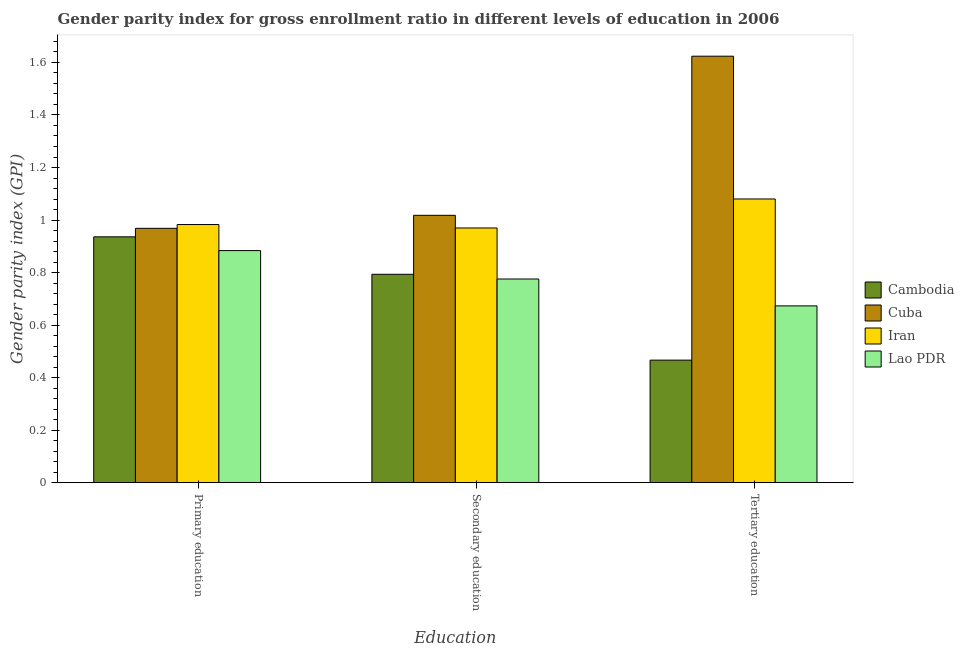How many bars are there on the 1st tick from the left?
Your answer should be very brief. 4. What is the label of the 1st group of bars from the left?
Your answer should be compact. Primary education. What is the gender parity index in primary education in Cambodia?
Make the answer very short. 0.94. Across all countries, what is the maximum gender parity index in primary education?
Ensure brevity in your answer.  0.98. Across all countries, what is the minimum gender parity index in tertiary education?
Provide a short and direct response. 0.47. In which country was the gender parity index in primary education maximum?
Offer a very short reply. Iran. In which country was the gender parity index in tertiary education minimum?
Offer a very short reply. Cambodia. What is the total gender parity index in tertiary education in the graph?
Keep it short and to the point. 3.84. What is the difference between the gender parity index in secondary education in Iran and that in Cuba?
Keep it short and to the point. -0.05. What is the difference between the gender parity index in secondary education in Iran and the gender parity index in tertiary education in Lao PDR?
Your answer should be compact. 0.3. What is the average gender parity index in primary education per country?
Provide a succinct answer. 0.94. What is the difference between the gender parity index in secondary education and gender parity index in primary education in Cuba?
Give a very brief answer. 0.05. In how many countries, is the gender parity index in tertiary education greater than 1.04 ?
Provide a short and direct response. 2. What is the ratio of the gender parity index in secondary education in Cuba to that in Iran?
Make the answer very short. 1.05. What is the difference between the highest and the second highest gender parity index in primary education?
Your answer should be compact. 0.01. What is the difference between the highest and the lowest gender parity index in secondary education?
Provide a succinct answer. 0.24. In how many countries, is the gender parity index in tertiary education greater than the average gender parity index in tertiary education taken over all countries?
Provide a short and direct response. 2. What does the 3rd bar from the left in Primary education represents?
Your answer should be very brief. Iran. What does the 1st bar from the right in Tertiary education represents?
Provide a short and direct response. Lao PDR. Is it the case that in every country, the sum of the gender parity index in primary education and gender parity index in secondary education is greater than the gender parity index in tertiary education?
Keep it short and to the point. Yes. How many bars are there?
Provide a short and direct response. 12. How many countries are there in the graph?
Offer a very short reply. 4. What is the difference between two consecutive major ticks on the Y-axis?
Offer a terse response. 0.2. Are the values on the major ticks of Y-axis written in scientific E-notation?
Keep it short and to the point. No. Does the graph contain any zero values?
Your answer should be very brief. No. Where does the legend appear in the graph?
Provide a succinct answer. Center right. How are the legend labels stacked?
Offer a terse response. Vertical. What is the title of the graph?
Offer a very short reply. Gender parity index for gross enrollment ratio in different levels of education in 2006. What is the label or title of the X-axis?
Your response must be concise. Education. What is the label or title of the Y-axis?
Keep it short and to the point. Gender parity index (GPI). What is the Gender parity index (GPI) in Cambodia in Primary education?
Offer a terse response. 0.94. What is the Gender parity index (GPI) of Cuba in Primary education?
Provide a succinct answer. 0.97. What is the Gender parity index (GPI) in Iran in Primary education?
Provide a short and direct response. 0.98. What is the Gender parity index (GPI) of Lao PDR in Primary education?
Provide a succinct answer. 0.88. What is the Gender parity index (GPI) in Cambodia in Secondary education?
Keep it short and to the point. 0.79. What is the Gender parity index (GPI) of Cuba in Secondary education?
Keep it short and to the point. 1.02. What is the Gender parity index (GPI) in Iran in Secondary education?
Offer a very short reply. 0.97. What is the Gender parity index (GPI) of Lao PDR in Secondary education?
Provide a short and direct response. 0.78. What is the Gender parity index (GPI) of Cambodia in Tertiary education?
Keep it short and to the point. 0.47. What is the Gender parity index (GPI) of Cuba in Tertiary education?
Your answer should be very brief. 1.62. What is the Gender parity index (GPI) of Iran in Tertiary education?
Give a very brief answer. 1.08. What is the Gender parity index (GPI) in Lao PDR in Tertiary education?
Your answer should be very brief. 0.67. Across all Education, what is the maximum Gender parity index (GPI) in Cambodia?
Provide a succinct answer. 0.94. Across all Education, what is the maximum Gender parity index (GPI) in Cuba?
Your answer should be compact. 1.62. Across all Education, what is the maximum Gender parity index (GPI) in Iran?
Provide a short and direct response. 1.08. Across all Education, what is the maximum Gender parity index (GPI) in Lao PDR?
Ensure brevity in your answer.  0.88. Across all Education, what is the minimum Gender parity index (GPI) of Cambodia?
Offer a terse response. 0.47. Across all Education, what is the minimum Gender parity index (GPI) in Cuba?
Your answer should be very brief. 0.97. Across all Education, what is the minimum Gender parity index (GPI) of Iran?
Your answer should be compact. 0.97. Across all Education, what is the minimum Gender parity index (GPI) of Lao PDR?
Offer a terse response. 0.67. What is the total Gender parity index (GPI) of Cambodia in the graph?
Your response must be concise. 2.2. What is the total Gender parity index (GPI) in Cuba in the graph?
Keep it short and to the point. 3.61. What is the total Gender parity index (GPI) of Iran in the graph?
Your answer should be compact. 3.03. What is the total Gender parity index (GPI) in Lao PDR in the graph?
Keep it short and to the point. 2.33. What is the difference between the Gender parity index (GPI) in Cambodia in Primary education and that in Secondary education?
Provide a succinct answer. 0.14. What is the difference between the Gender parity index (GPI) in Cuba in Primary education and that in Secondary education?
Provide a short and direct response. -0.05. What is the difference between the Gender parity index (GPI) in Iran in Primary education and that in Secondary education?
Ensure brevity in your answer.  0.01. What is the difference between the Gender parity index (GPI) in Lao PDR in Primary education and that in Secondary education?
Provide a short and direct response. 0.11. What is the difference between the Gender parity index (GPI) in Cambodia in Primary education and that in Tertiary education?
Your response must be concise. 0.47. What is the difference between the Gender parity index (GPI) in Cuba in Primary education and that in Tertiary education?
Your answer should be compact. -0.66. What is the difference between the Gender parity index (GPI) in Iran in Primary education and that in Tertiary education?
Provide a short and direct response. -0.1. What is the difference between the Gender parity index (GPI) in Lao PDR in Primary education and that in Tertiary education?
Provide a succinct answer. 0.21. What is the difference between the Gender parity index (GPI) of Cambodia in Secondary education and that in Tertiary education?
Your answer should be compact. 0.33. What is the difference between the Gender parity index (GPI) of Cuba in Secondary education and that in Tertiary education?
Provide a succinct answer. -0.61. What is the difference between the Gender parity index (GPI) in Iran in Secondary education and that in Tertiary education?
Your answer should be compact. -0.11. What is the difference between the Gender parity index (GPI) of Lao PDR in Secondary education and that in Tertiary education?
Offer a terse response. 0.1. What is the difference between the Gender parity index (GPI) in Cambodia in Primary education and the Gender parity index (GPI) in Cuba in Secondary education?
Keep it short and to the point. -0.08. What is the difference between the Gender parity index (GPI) of Cambodia in Primary education and the Gender parity index (GPI) of Iran in Secondary education?
Your answer should be very brief. -0.03. What is the difference between the Gender parity index (GPI) of Cambodia in Primary education and the Gender parity index (GPI) of Lao PDR in Secondary education?
Provide a short and direct response. 0.16. What is the difference between the Gender parity index (GPI) of Cuba in Primary education and the Gender parity index (GPI) of Iran in Secondary education?
Your answer should be very brief. -0. What is the difference between the Gender parity index (GPI) of Cuba in Primary education and the Gender parity index (GPI) of Lao PDR in Secondary education?
Make the answer very short. 0.19. What is the difference between the Gender parity index (GPI) in Iran in Primary education and the Gender parity index (GPI) in Lao PDR in Secondary education?
Your answer should be very brief. 0.21. What is the difference between the Gender parity index (GPI) of Cambodia in Primary education and the Gender parity index (GPI) of Cuba in Tertiary education?
Offer a terse response. -0.69. What is the difference between the Gender parity index (GPI) of Cambodia in Primary education and the Gender parity index (GPI) of Iran in Tertiary education?
Ensure brevity in your answer.  -0.14. What is the difference between the Gender parity index (GPI) of Cambodia in Primary education and the Gender parity index (GPI) of Lao PDR in Tertiary education?
Provide a short and direct response. 0.26. What is the difference between the Gender parity index (GPI) of Cuba in Primary education and the Gender parity index (GPI) of Iran in Tertiary education?
Keep it short and to the point. -0.11. What is the difference between the Gender parity index (GPI) in Cuba in Primary education and the Gender parity index (GPI) in Lao PDR in Tertiary education?
Provide a succinct answer. 0.3. What is the difference between the Gender parity index (GPI) of Iran in Primary education and the Gender parity index (GPI) of Lao PDR in Tertiary education?
Provide a succinct answer. 0.31. What is the difference between the Gender parity index (GPI) of Cambodia in Secondary education and the Gender parity index (GPI) of Cuba in Tertiary education?
Your response must be concise. -0.83. What is the difference between the Gender parity index (GPI) of Cambodia in Secondary education and the Gender parity index (GPI) of Iran in Tertiary education?
Keep it short and to the point. -0.29. What is the difference between the Gender parity index (GPI) in Cambodia in Secondary education and the Gender parity index (GPI) in Lao PDR in Tertiary education?
Your answer should be very brief. 0.12. What is the difference between the Gender parity index (GPI) in Cuba in Secondary education and the Gender parity index (GPI) in Iran in Tertiary education?
Your response must be concise. -0.06. What is the difference between the Gender parity index (GPI) in Cuba in Secondary education and the Gender parity index (GPI) in Lao PDR in Tertiary education?
Your answer should be very brief. 0.34. What is the difference between the Gender parity index (GPI) in Iran in Secondary education and the Gender parity index (GPI) in Lao PDR in Tertiary education?
Your response must be concise. 0.3. What is the average Gender parity index (GPI) in Cambodia per Education?
Your response must be concise. 0.73. What is the average Gender parity index (GPI) of Cuba per Education?
Your response must be concise. 1.2. What is the average Gender parity index (GPI) in Iran per Education?
Keep it short and to the point. 1.01. What is the average Gender parity index (GPI) in Lao PDR per Education?
Offer a terse response. 0.78. What is the difference between the Gender parity index (GPI) of Cambodia and Gender parity index (GPI) of Cuba in Primary education?
Keep it short and to the point. -0.03. What is the difference between the Gender parity index (GPI) in Cambodia and Gender parity index (GPI) in Iran in Primary education?
Give a very brief answer. -0.05. What is the difference between the Gender parity index (GPI) of Cambodia and Gender parity index (GPI) of Lao PDR in Primary education?
Ensure brevity in your answer.  0.05. What is the difference between the Gender parity index (GPI) in Cuba and Gender parity index (GPI) in Iran in Primary education?
Provide a short and direct response. -0.01. What is the difference between the Gender parity index (GPI) in Cuba and Gender parity index (GPI) in Lao PDR in Primary education?
Provide a short and direct response. 0.08. What is the difference between the Gender parity index (GPI) of Iran and Gender parity index (GPI) of Lao PDR in Primary education?
Provide a succinct answer. 0.1. What is the difference between the Gender parity index (GPI) of Cambodia and Gender parity index (GPI) of Cuba in Secondary education?
Your answer should be very brief. -0.22. What is the difference between the Gender parity index (GPI) in Cambodia and Gender parity index (GPI) in Iran in Secondary education?
Make the answer very short. -0.18. What is the difference between the Gender parity index (GPI) of Cambodia and Gender parity index (GPI) of Lao PDR in Secondary education?
Your answer should be very brief. 0.02. What is the difference between the Gender parity index (GPI) of Cuba and Gender parity index (GPI) of Iran in Secondary education?
Your response must be concise. 0.05. What is the difference between the Gender parity index (GPI) in Cuba and Gender parity index (GPI) in Lao PDR in Secondary education?
Keep it short and to the point. 0.24. What is the difference between the Gender parity index (GPI) of Iran and Gender parity index (GPI) of Lao PDR in Secondary education?
Your answer should be compact. 0.19. What is the difference between the Gender parity index (GPI) in Cambodia and Gender parity index (GPI) in Cuba in Tertiary education?
Your answer should be very brief. -1.16. What is the difference between the Gender parity index (GPI) in Cambodia and Gender parity index (GPI) in Iran in Tertiary education?
Provide a short and direct response. -0.61. What is the difference between the Gender parity index (GPI) of Cambodia and Gender parity index (GPI) of Lao PDR in Tertiary education?
Keep it short and to the point. -0.21. What is the difference between the Gender parity index (GPI) in Cuba and Gender parity index (GPI) in Iran in Tertiary education?
Offer a very short reply. 0.54. What is the difference between the Gender parity index (GPI) in Cuba and Gender parity index (GPI) in Lao PDR in Tertiary education?
Give a very brief answer. 0.95. What is the difference between the Gender parity index (GPI) in Iran and Gender parity index (GPI) in Lao PDR in Tertiary education?
Your answer should be compact. 0.41. What is the ratio of the Gender parity index (GPI) of Cambodia in Primary education to that in Secondary education?
Ensure brevity in your answer.  1.18. What is the ratio of the Gender parity index (GPI) in Cuba in Primary education to that in Secondary education?
Provide a short and direct response. 0.95. What is the ratio of the Gender parity index (GPI) of Iran in Primary education to that in Secondary education?
Provide a short and direct response. 1.01. What is the ratio of the Gender parity index (GPI) in Lao PDR in Primary education to that in Secondary education?
Give a very brief answer. 1.14. What is the ratio of the Gender parity index (GPI) in Cambodia in Primary education to that in Tertiary education?
Give a very brief answer. 2.01. What is the ratio of the Gender parity index (GPI) of Cuba in Primary education to that in Tertiary education?
Keep it short and to the point. 0.6. What is the ratio of the Gender parity index (GPI) of Iran in Primary education to that in Tertiary education?
Ensure brevity in your answer.  0.91. What is the ratio of the Gender parity index (GPI) in Lao PDR in Primary education to that in Tertiary education?
Your answer should be very brief. 1.31. What is the ratio of the Gender parity index (GPI) in Cambodia in Secondary education to that in Tertiary education?
Provide a succinct answer. 1.7. What is the ratio of the Gender parity index (GPI) of Cuba in Secondary education to that in Tertiary education?
Provide a succinct answer. 0.63. What is the ratio of the Gender parity index (GPI) of Iran in Secondary education to that in Tertiary education?
Your response must be concise. 0.9. What is the ratio of the Gender parity index (GPI) in Lao PDR in Secondary education to that in Tertiary education?
Provide a short and direct response. 1.15. What is the difference between the highest and the second highest Gender parity index (GPI) in Cambodia?
Give a very brief answer. 0.14. What is the difference between the highest and the second highest Gender parity index (GPI) in Cuba?
Your answer should be very brief. 0.61. What is the difference between the highest and the second highest Gender parity index (GPI) in Iran?
Make the answer very short. 0.1. What is the difference between the highest and the second highest Gender parity index (GPI) in Lao PDR?
Keep it short and to the point. 0.11. What is the difference between the highest and the lowest Gender parity index (GPI) in Cambodia?
Your answer should be compact. 0.47. What is the difference between the highest and the lowest Gender parity index (GPI) in Cuba?
Offer a very short reply. 0.66. What is the difference between the highest and the lowest Gender parity index (GPI) in Iran?
Offer a very short reply. 0.11. What is the difference between the highest and the lowest Gender parity index (GPI) in Lao PDR?
Ensure brevity in your answer.  0.21. 